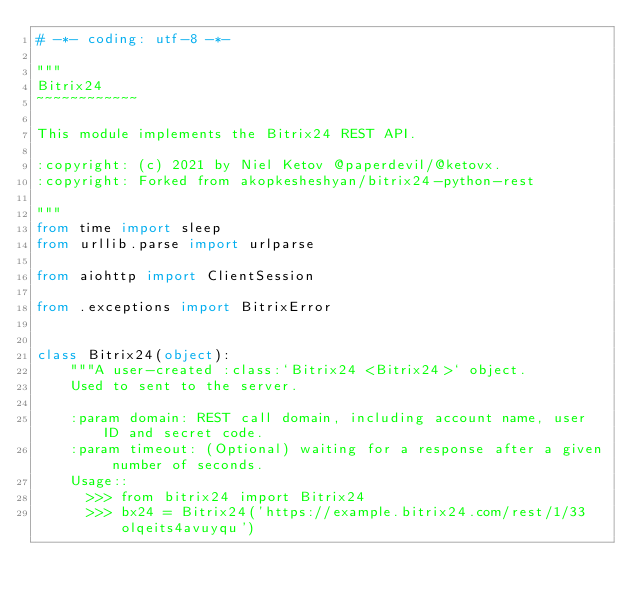Convert code to text. <code><loc_0><loc_0><loc_500><loc_500><_Python_># -*- coding: utf-8 -*-

"""
Bitrix24
~~~~~~~~~~~~

This module implements the Bitrix24 REST API.

:copyright: (c) 2021 by Niel Ketov @paperdevil/@ketovx.
:copyright: Forked from akopkesheshyan/bitrix24-python-rest

"""
from time import sleep
from urllib.parse import urlparse

from aiohttp import ClientSession

from .exceptions import BitrixError


class Bitrix24(object):
    """A user-created :class:`Bitrix24 <Bitrix24>` object.
    Used to sent to the server.

    :param domain: REST call domain, including account name, user ID and secret code.
    :param timeout: (Optional) waiting for a response after a given number of seconds.
    Usage::
      >>> from bitrix24 import Bitrix24
      >>> bx24 = Bitrix24('https://example.bitrix24.com/rest/1/33olqeits4avuyqu')</code> 